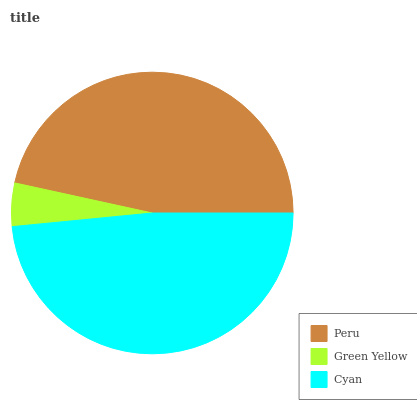Is Green Yellow the minimum?
Answer yes or no. Yes. Is Cyan the maximum?
Answer yes or no. Yes. Is Cyan the minimum?
Answer yes or no. No. Is Green Yellow the maximum?
Answer yes or no. No. Is Cyan greater than Green Yellow?
Answer yes or no. Yes. Is Green Yellow less than Cyan?
Answer yes or no. Yes. Is Green Yellow greater than Cyan?
Answer yes or no. No. Is Cyan less than Green Yellow?
Answer yes or no. No. Is Peru the high median?
Answer yes or no. Yes. Is Peru the low median?
Answer yes or no. Yes. Is Green Yellow the high median?
Answer yes or no. No. Is Cyan the low median?
Answer yes or no. No. 